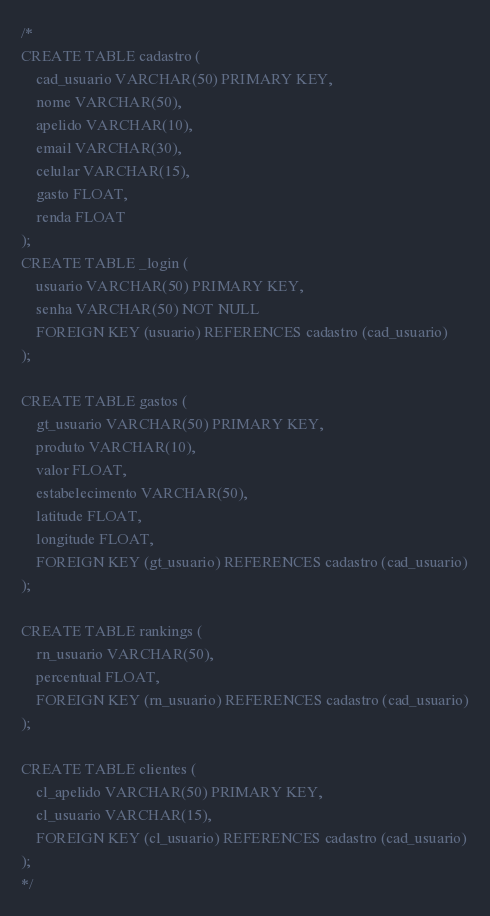Convert code to text. <code><loc_0><loc_0><loc_500><loc_500><_SQL_>/*
CREATE TABLE cadastro (
    cad_usuario VARCHAR(50) PRIMARY KEY,
    nome VARCHAR(50),
    apelido VARCHAR(10),
    email VARCHAR(30),
    celular VARCHAR(15),
    gasto FLOAT,
    renda FLOAT
);
CREATE TABLE _login (
    usuario VARCHAR(50) PRIMARY KEY,
    senha VARCHAR(50) NOT NULL
    FOREIGN KEY (usuario) REFERENCES cadastro (cad_usuario)
);

CREATE TABLE gastos (
    gt_usuario VARCHAR(50) PRIMARY KEY,
    produto VARCHAR(10),
    valor FLOAT,
    estabelecimento VARCHAR(50),
    latitude FLOAT,
    longitude FLOAT,
    FOREIGN KEY (gt_usuario) REFERENCES cadastro (cad_usuario)
);

CREATE TABLE rankings (
    rn_usuario VARCHAR(50),
    percentual FLOAT,
    FOREIGN KEY (rn_usuario) REFERENCES cadastro (cad_usuario)
);

CREATE TABLE clientes (
    cl_apelido VARCHAR(50) PRIMARY KEY,
    cl_usuario VARCHAR(15),
    FOREIGN KEY (cl_usuario) REFERENCES cadastro (cad_usuario)
);
*/</code> 